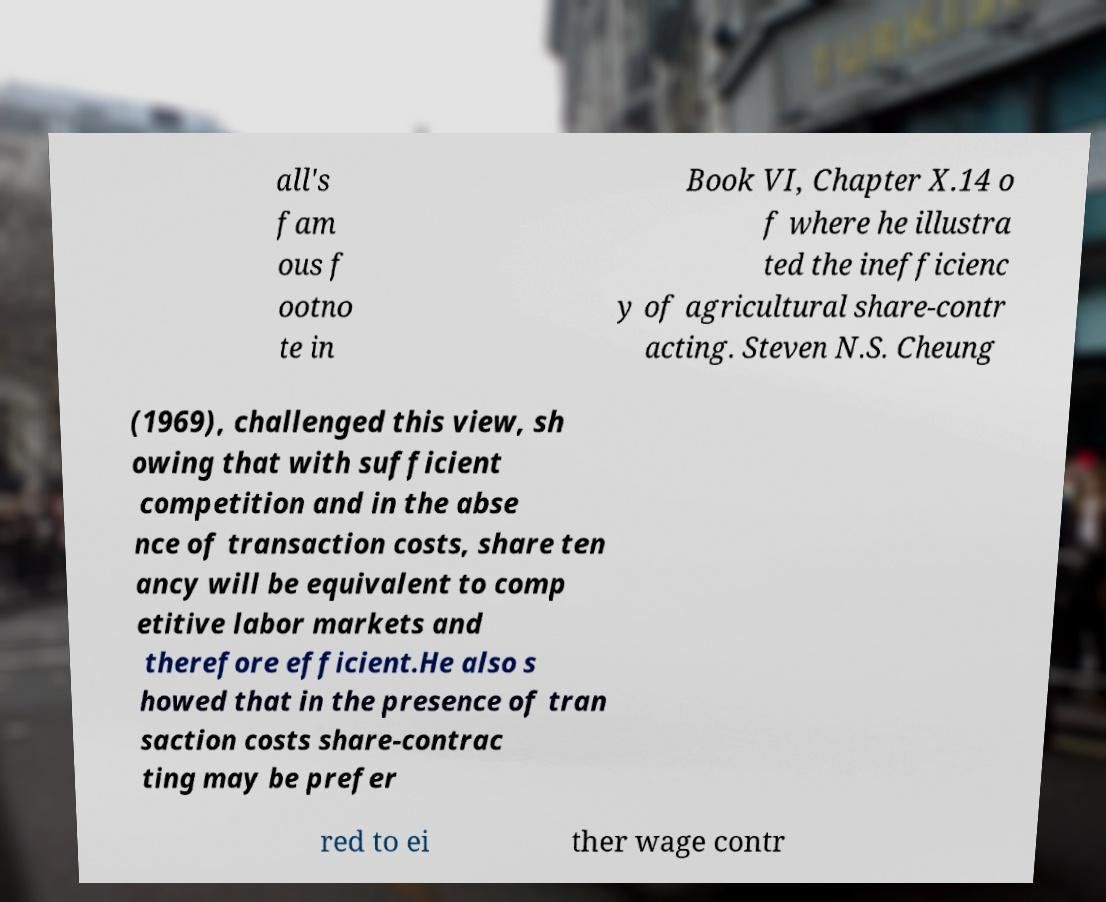There's text embedded in this image that I need extracted. Can you transcribe it verbatim? all's fam ous f ootno te in Book VI, Chapter X.14 o f where he illustra ted the inefficienc y of agricultural share-contr acting. Steven N.S. Cheung (1969), challenged this view, sh owing that with sufficient competition and in the abse nce of transaction costs, share ten ancy will be equivalent to comp etitive labor markets and therefore efficient.He also s howed that in the presence of tran saction costs share-contrac ting may be prefer red to ei ther wage contr 